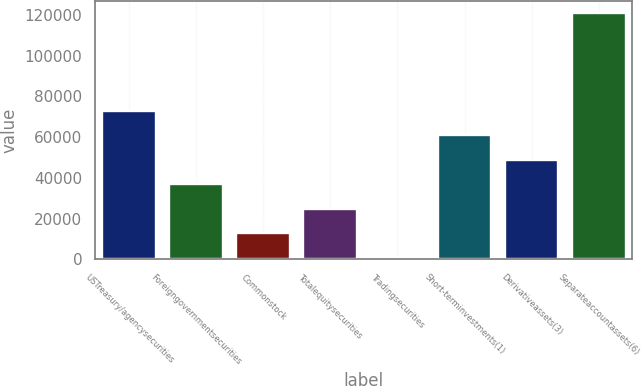Convert chart to OTSL. <chart><loc_0><loc_0><loc_500><loc_500><bar_chart><fcel>USTreasury/agencysecurities<fcel>Foreigngovernmentsecurities<fcel>Commonstock<fcel>Totalequitysecurities<fcel>Tradingsecurities<fcel>Short-terminvestments(1)<fcel>Derivativeassets(3)<fcel>Separateaccountassets(6)<nl><fcel>72881.8<fcel>36913.9<fcel>12935.3<fcel>24924.6<fcel>946<fcel>60892.5<fcel>48903.2<fcel>120839<nl></chart> 